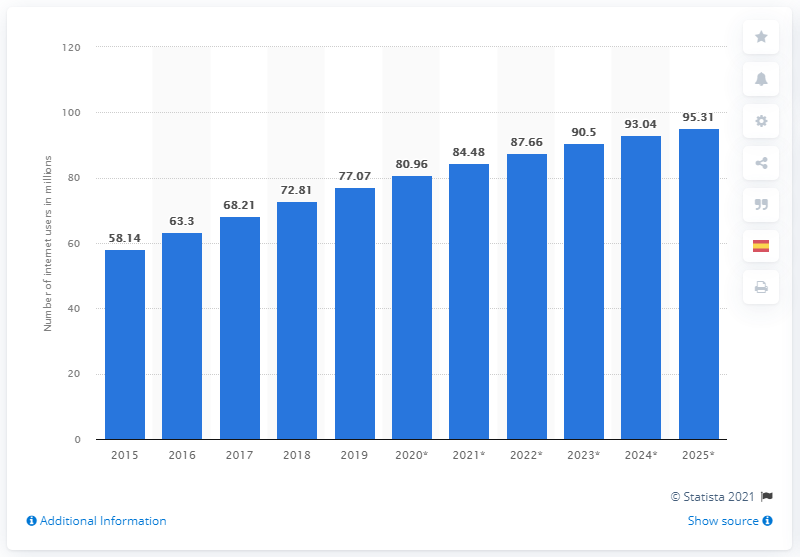Identify some key points in this picture. By 2025, it is projected that there will be approximately 95.31% of the world's population who will be using the internet. As of 2019, Mexico had 77.07 million internet users. 